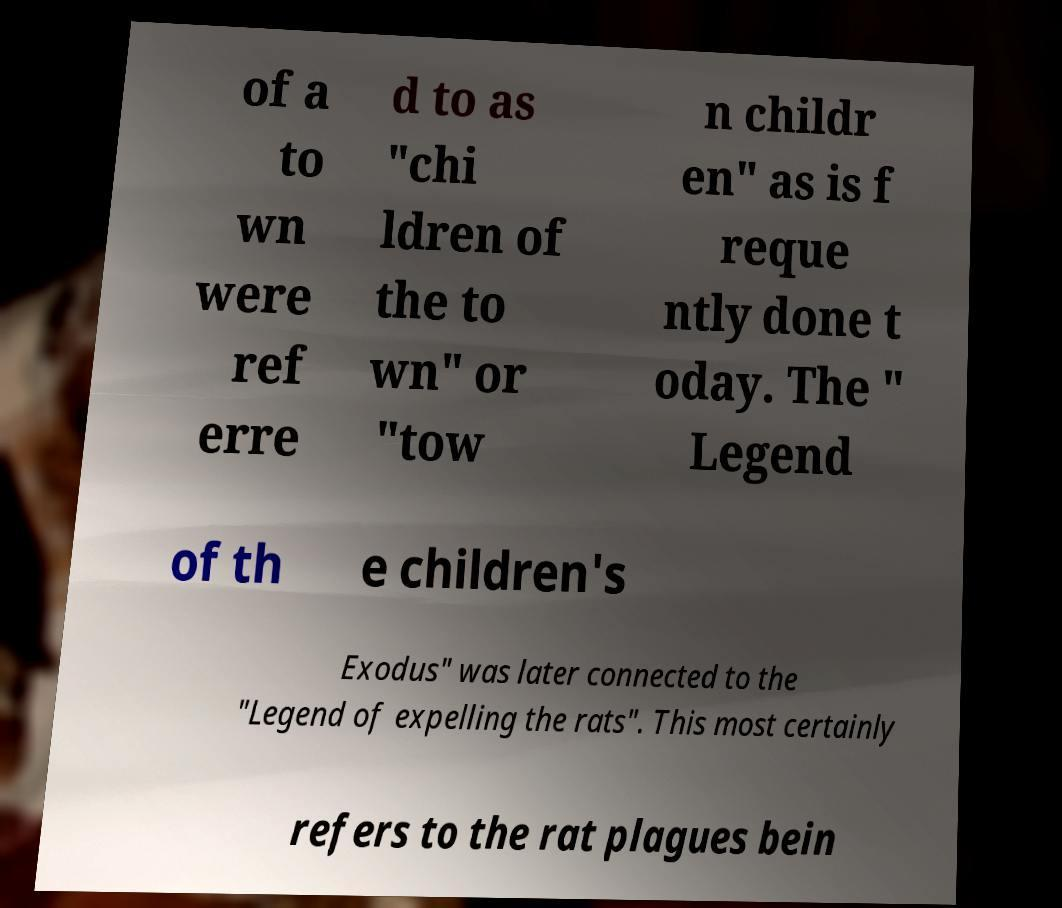What messages or text are displayed in this image? I need them in a readable, typed format. of a to wn were ref erre d to as "chi ldren of the to wn" or "tow n childr en" as is f reque ntly done t oday. The " Legend of th e children's Exodus" was later connected to the "Legend of expelling the rats". This most certainly refers to the rat plagues bein 